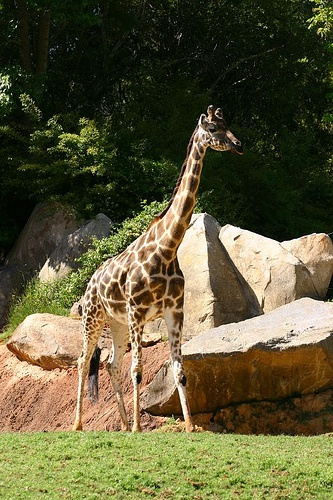Describe the objects in this image and their specific colors. I can see a giraffe in black, beige, tan, and maroon tones in this image. 